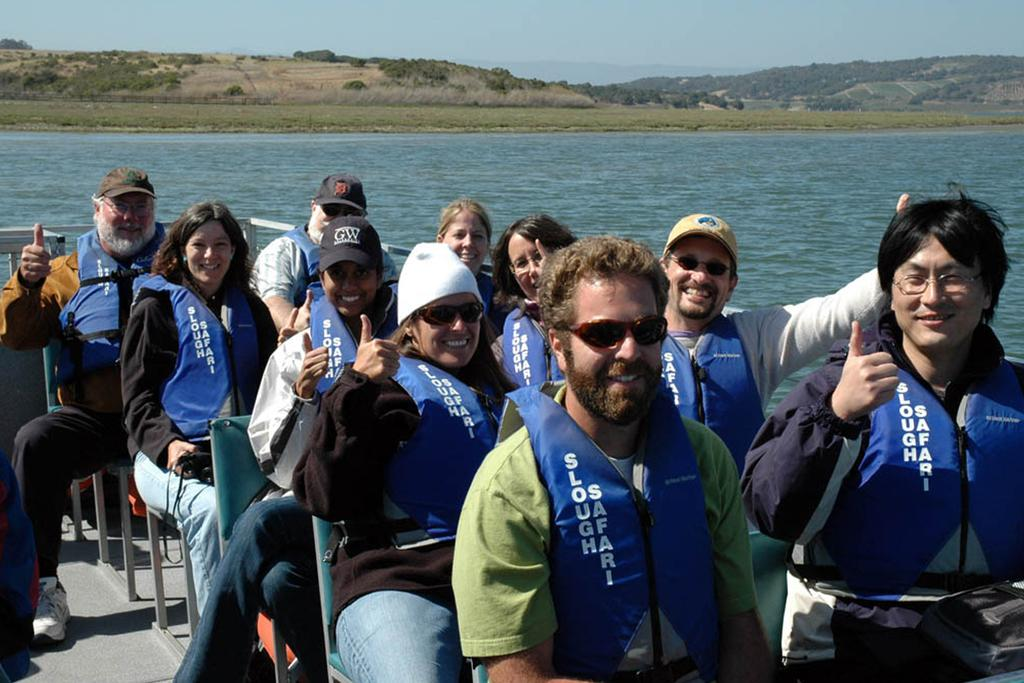How many people are in the image? There is a group of people in the image. What are the people doing in the image? The people are sitting in a boat. Where is the boat located in the image? The boat is on the water. What can be seen in the background of the image? There are trees, hills, and the sky visible in the background of the image. What type of music can be heard coming from the boat in the image? There is no indication in the image that music is being played or heard, so it's not possible to determine what, if any, music might be present. 